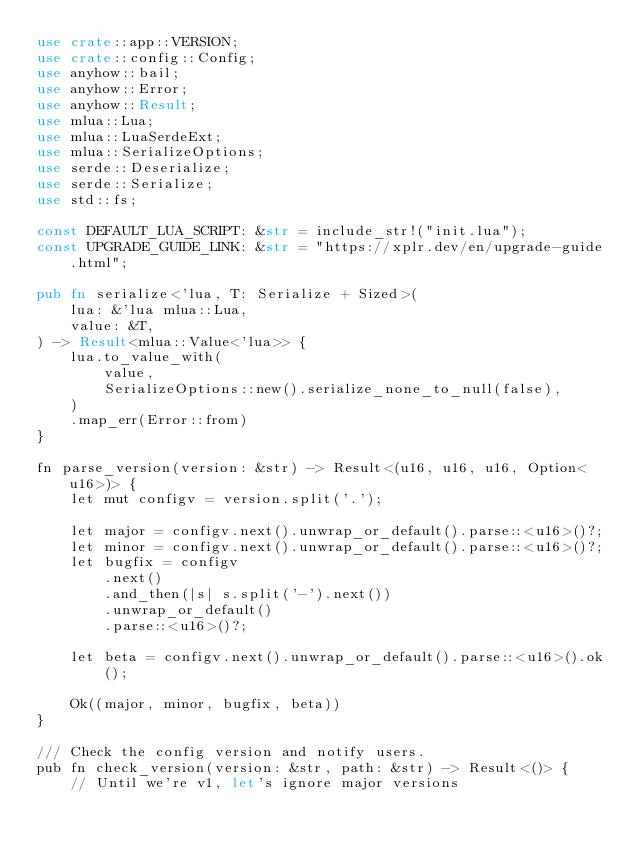Convert code to text. <code><loc_0><loc_0><loc_500><loc_500><_Rust_>use crate::app::VERSION;
use crate::config::Config;
use anyhow::bail;
use anyhow::Error;
use anyhow::Result;
use mlua::Lua;
use mlua::LuaSerdeExt;
use mlua::SerializeOptions;
use serde::Deserialize;
use serde::Serialize;
use std::fs;

const DEFAULT_LUA_SCRIPT: &str = include_str!("init.lua");
const UPGRADE_GUIDE_LINK: &str = "https://xplr.dev/en/upgrade-guide.html";

pub fn serialize<'lua, T: Serialize + Sized>(
    lua: &'lua mlua::Lua,
    value: &T,
) -> Result<mlua::Value<'lua>> {
    lua.to_value_with(
        value,
        SerializeOptions::new().serialize_none_to_null(false),
    )
    .map_err(Error::from)
}

fn parse_version(version: &str) -> Result<(u16, u16, u16, Option<u16>)> {
    let mut configv = version.split('.');

    let major = configv.next().unwrap_or_default().parse::<u16>()?;
    let minor = configv.next().unwrap_or_default().parse::<u16>()?;
    let bugfix = configv
        .next()
        .and_then(|s| s.split('-').next())
        .unwrap_or_default()
        .parse::<u16>()?;

    let beta = configv.next().unwrap_or_default().parse::<u16>().ok();

    Ok((major, minor, bugfix, beta))
}

/// Check the config version and notify users.
pub fn check_version(version: &str, path: &str) -> Result<()> {
    // Until we're v1, let's ignore major versions</code> 